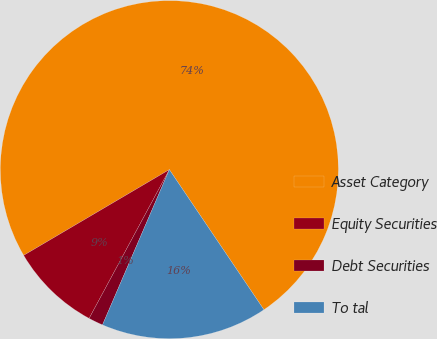Convert chart. <chart><loc_0><loc_0><loc_500><loc_500><pie_chart><fcel>Asset Category<fcel>Equity Securities<fcel>Debt Securities<fcel>To tal<nl><fcel>74.01%<fcel>8.66%<fcel>1.4%<fcel>15.92%<nl></chart> 